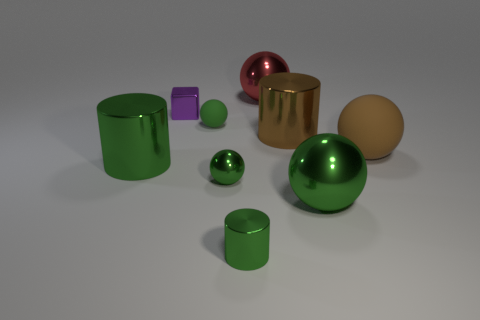There is a rubber thing that is behind the brown cylinder; is it the same size as the purple metal object?
Provide a succinct answer. Yes. Is the number of tiny cyan metal objects less than the number of large brown metal cylinders?
Your answer should be very brief. Yes. What is the shape of the large object that is the same color as the big matte ball?
Keep it short and to the point. Cylinder. There is a big red object; what number of red metallic things are behind it?
Offer a very short reply. 0. Is the shape of the brown matte object the same as the tiny purple metallic thing?
Ensure brevity in your answer.  No. What number of small things are in front of the cube and behind the large brown sphere?
Provide a short and direct response. 1. What number of objects are purple metallic things or large brown things in front of the large brown metal cylinder?
Provide a short and direct response. 2. Are there more red objects than yellow balls?
Give a very brief answer. Yes. What shape is the big green metal thing that is right of the green rubber sphere?
Your answer should be compact. Sphere. How many big blue rubber things are the same shape as the big red object?
Give a very brief answer. 0. 